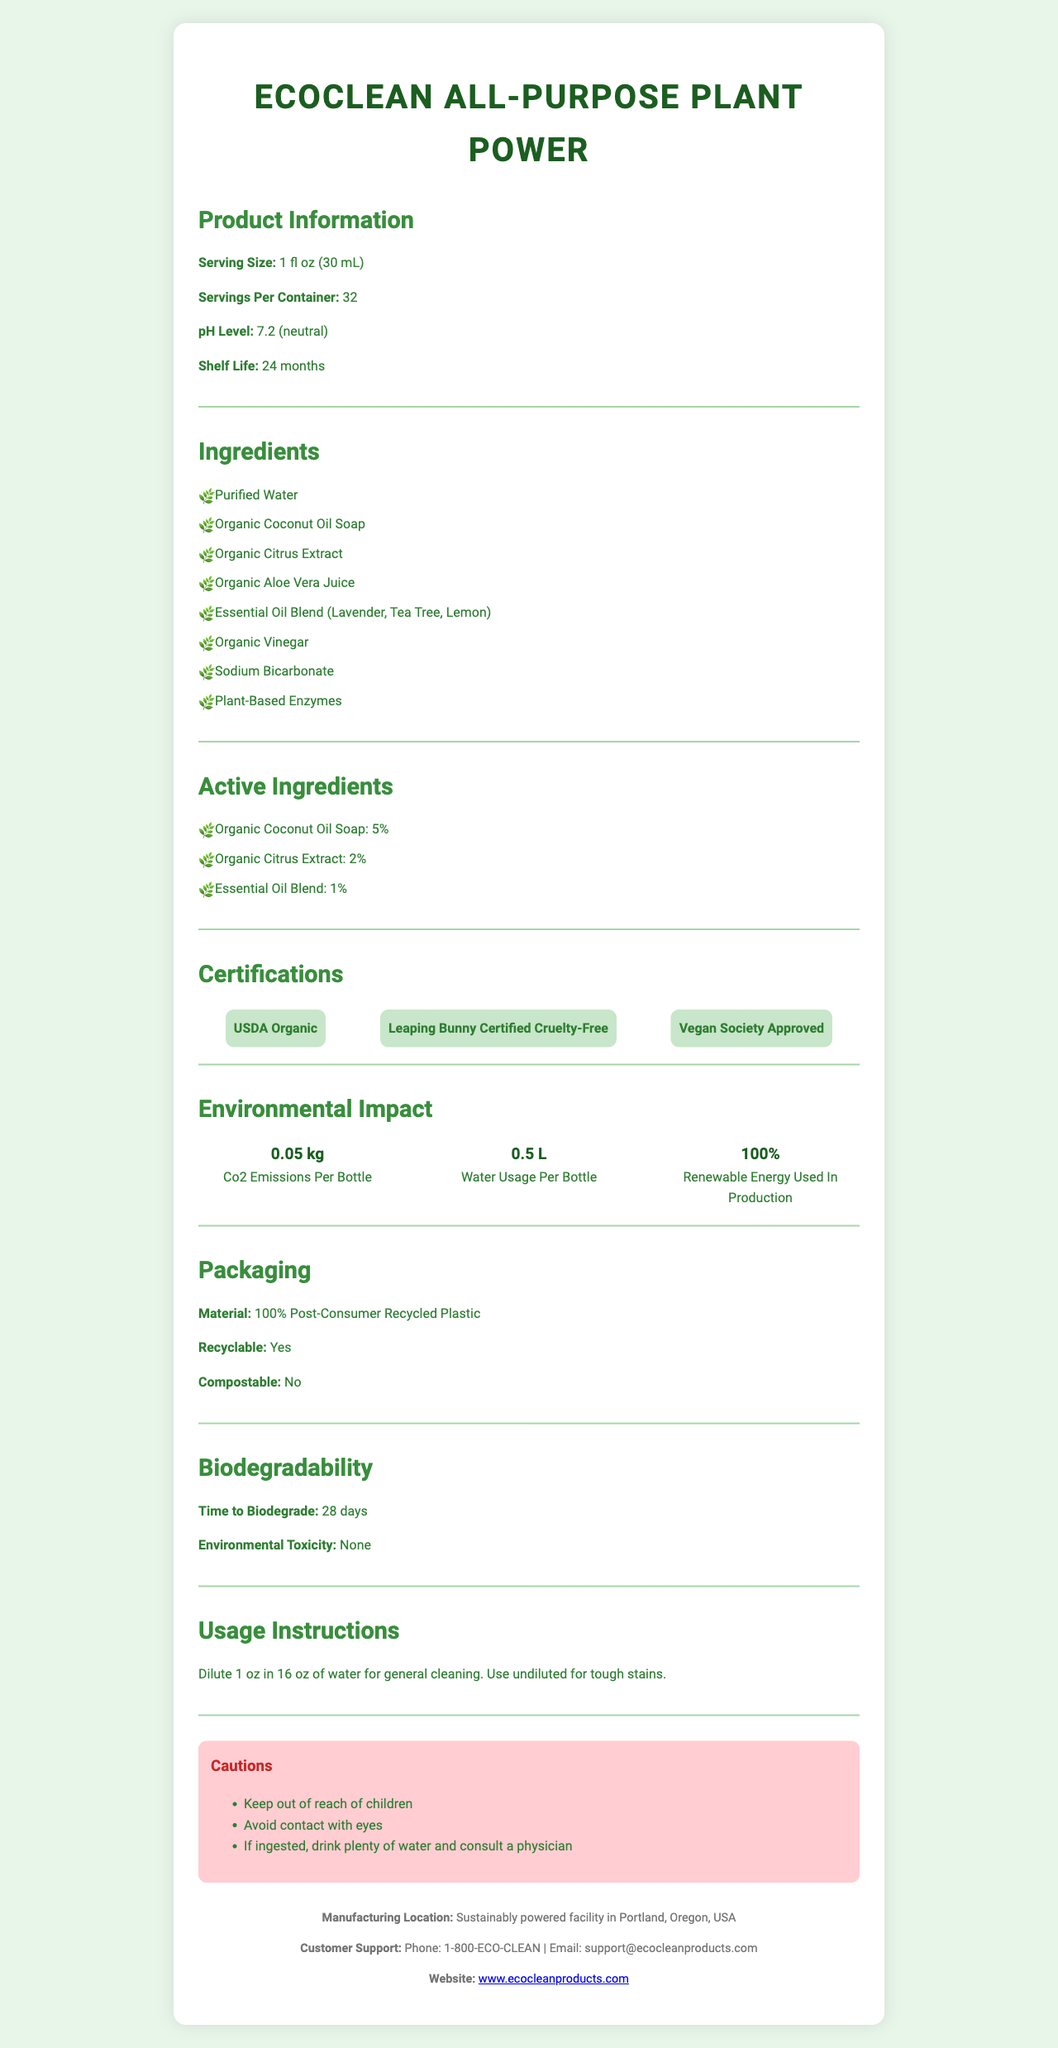what is the serving size of the EcoClean All-Purpose Plant Power? The serving size is directly stated in the "Product Information" section of the document.
Answer: 1 fl oz (30 mL) how many servings are there per container? The number of servings per container is provided in the "Product Information" section.
Answer: 32 what is the pH level of this cleaning product? The pH level is stated in the "Product Information" section.
Answer: 7.2 (neutral) what is the certification status of EcoClean All-Purpose Plant Power? The certifications are listed in the "Certifications" section.
Answer: USDA Organic, Leaping Bunny Certified Cruelty-Free, Vegan Society Approved what are the main active ingredients? The active ingredients and their percentages are provided in the "Active Ingredients" section.
Answer: Organic Coconut Oil Soap (5%), Organic Citrus Extract (2%), Essential Oil Blend (1%) which ingredient is used in the highest amount among the active ingredients? A. Organic Citrus Extract B. Organic Coconut Oil Soap C. Essential Oil Blend Organic Coconut Oil Soap is used in the highest amount at 5%, as seen in the "Active Ingredients" section.
Answer: B. Organic Coconut Oil Soap what is the environmental toxicity of the product after it biodegrades? A. High B. Moderate C. None The document states that the environmental toxicity is "None" in the "Biodegradability" section.
Answer: C. None what is the recommended dilution ratio for general cleaning? The usage instructions specify this dilution ratio for general cleaning.
Answer: Dilute 1 oz in 16 oz of water are the packaging materials of this product recyclable? The packaging section mentions that the material is 100% post-consumer recycled plastic and is recyclable.
Answer: Yes does the product utilize renewable energy during its production? The environmental impact section states that 100% renewable energy is used in production.
Answer: Yes where is this product manufactured? The manufacturing location is listed at the end of the document in the footer.
Answer: Portland, Oregon, USA how long does it take for the product to biodegrade? The time to biodegrade is specified as 28 days in the "Biodegradability" section.
Answer: 28 days what should be done in case the product is ingested? The cautions section provides this instruction.
Answer: Drink plenty of water and consult a physician are there any known cautions for EcoClean All-Purpose Plant Power? These cautions are listed in the "Cautions" section.
Answer: Keep out of reach of children, Avoid contact with eyes, If ingested, drink plenty of water and consult a physician which essential oils are included in the blend used in this product? The essential oils are listed under the "Ingredients" section as part of the essential oil blend.
Answer: Lavender, Tea Tree, Lemon how should the product be stored for optimal shelf life? Storage instructions are provided in the "Product Information" section.
Answer: Store in a cool, dry place away from direct sunlight explain the environmental impact of using EcoClean All-Purpose Plant Power. This information is detailed in the "Environmental Impact" section of the document.
Answer: The product has a low environmental impact with 0.05 kg CO2 emissions and 0.5 L water usage per bottle, and it is produced using 100% renewable energy. is this product compostable? The "Packaging" section states that the product is recyclable, but not compostable.
Answer: No what is the CO2 emission per bottle? This information is provided in the "Environmental Impact" section.
Answer: 0.05 kg summarize the main points of the EcoClean All-Purpose Plant Power document. This summary encapsulates the key details found throughout various sections of the document.
Answer: EcoClean All-Purpose Plant Power is an organic, plant-based household cleaner with biodegradable ingredients. Its active ingredients include organic coconut oil soap, citrus extract, and essential oils, and it boasts certifications like USDA Organic and Leaping Bunny Certified Cruelty-Free. The product's packaging is made from 100% post-consumer recycled plastic and is recyclable. Its production utilizes 100% renewable energy, with a minimal environmental footprint. Instructions for usage, storage, and safety cautions are clearly provided. where can more information about the product be found? The document does not provide additional URLs or physical locations beyond the customer support contact details.
Answer: I don't know 